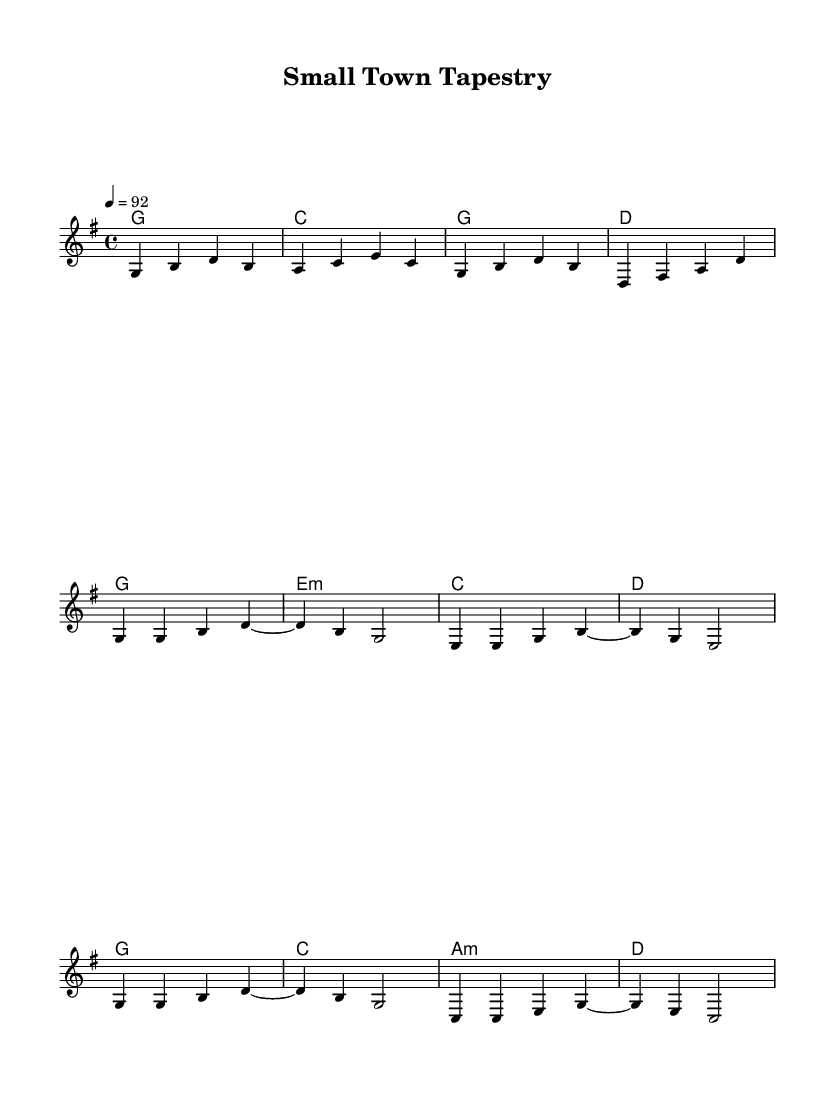What is the key signature of this music? The key signature is indicated by the key signature symbol at the beginning of the staff. It shows one sharp (F#), indicating G major or E minor.
Answer: G major What is the time signature of this music? The time signature is displayed as a fraction at the beginning of the staff. Here, it is 4/4, which means there are four beats in each measure and a quarter note receives one beat.
Answer: 4/4 What is the tempo marking of this music? The tempo marking is indicated at the beginning of the score, showing a metronome marking of 92 beats per minute. This indicates how fast the piece should be played.
Answer: 92 What is the first chord of the piece? The first chord is located in the harmony section's introduction. Following the chord structure in the chord mode, the first chord is G major.
Answer: G How many measures are in the first verse? The number of measures can be counted in the melody section of the score. There are four measures in the first verse (partial).
Answer: 4 What is the pattern of the chorus compared to the verse? By examining both the chorus and the verse, the chorus follows a similar rhythmic structure but varies the harmony. The chorus emphasizes the G major and C major chords, providing a contrast to the verse's harmony.
Answer: Contrast What themes are prevalent in the lyrics as inferred from the music? The musical structure, particularly in contemporary country, often highlights relationships and community. Given the title "Small Town Tapestry," themes likely include small-town life, relationships, and community dynamics.
Answer: Relationships 